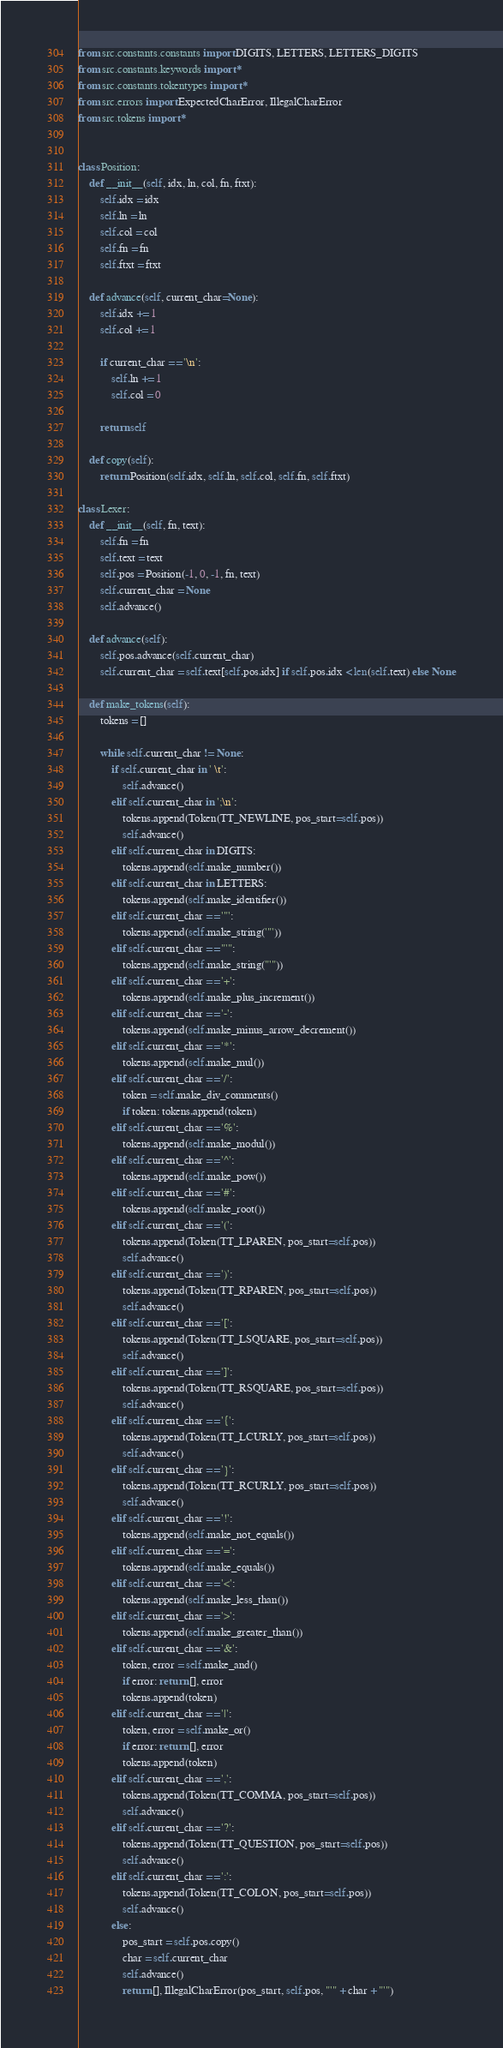Convert code to text. <code><loc_0><loc_0><loc_500><loc_500><_Python_>from src.constants.constants import DIGITS, LETTERS, LETTERS_DIGITS
from src.constants.keywords import *
from src.constants.tokentypes import *
from src.errors import ExpectedCharError, IllegalCharError
from src.tokens import *


class Position:
	def __init__(self, idx, ln, col, fn, ftxt):
		self.idx = idx
		self.ln = ln
		self.col = col
		self.fn = fn
		self.ftxt = ftxt
	
	def advance(self, current_char=None):
		self.idx += 1
		self.col += 1

		if current_char == '\n':
			self.ln += 1
			self.col = 0
		
		return self
	
	def copy(self):
		return Position(self.idx, self.ln, self.col, self.fn, self.ftxt)

class Lexer:
	def __init__(self, fn, text):
		self.fn = fn
		self.text = text
		self.pos = Position(-1, 0, -1, fn, text)
		self.current_char = None
		self.advance()

	def advance(self):
		self.pos.advance(self.current_char)
		self.current_char = self.text[self.pos.idx] if self.pos.idx < len(self.text) else None

	def make_tokens(self):
		tokens = []

		while self.current_char != None:
			if self.current_char in ' \t':
				self.advance()
			elif self.current_char in ';\n':
				tokens.append(Token(TT_NEWLINE, pos_start=self.pos))
				self.advance()
			elif self.current_char in DIGITS:
				tokens.append(self.make_number())
			elif self.current_char in LETTERS:
				tokens.append(self.make_identifier())
			elif self.current_char == '"':
				tokens.append(self.make_string('"'))
			elif self.current_char == "'":
				tokens.append(self.make_string("'"))
			elif self.current_char == '+':
				tokens.append(self.make_plus_increment())
			elif self.current_char == '-':
				tokens.append(self.make_minus_arrow_decrement())
			elif self.current_char == '*':
				tokens.append(self.make_mul())
			elif self.current_char == '/':
				token = self.make_div_comments()
				if token: tokens.append(token)
			elif self.current_char == '%':
				tokens.append(self.make_modul())
			elif self.current_char == '^':
				tokens.append(self.make_pow())
			elif self.current_char == '#':
				tokens.append(self.make_root())
			elif self.current_char == '(':
				tokens.append(Token(TT_LPAREN, pos_start=self.pos))
				self.advance()
			elif self.current_char == ')':
				tokens.append(Token(TT_RPAREN, pos_start=self.pos))
				self.advance()
			elif self.current_char == '[':
				tokens.append(Token(TT_LSQUARE, pos_start=self.pos))
				self.advance()
			elif self.current_char == ']':
				tokens.append(Token(TT_RSQUARE, pos_start=self.pos))
				self.advance()
			elif self.current_char == '{':
				tokens.append(Token(TT_LCURLY, pos_start=self.pos))
				self.advance()
			elif self.current_char == '}':
				tokens.append(Token(TT_RCURLY, pos_start=self.pos))
				self.advance()
			elif self.current_char == '!':
				tokens.append(self.make_not_equals())
			elif self.current_char == '=':
				tokens.append(self.make_equals())
			elif self.current_char == '<':
				tokens.append(self.make_less_than())
			elif self.current_char == '>':
				tokens.append(self.make_greater_than())
			elif self.current_char == '&':
				token, error = self.make_and()
				if error: return [], error
				tokens.append(token)
			elif self.current_char == '|':
				token, error = self.make_or()
				if error: return [], error
				tokens.append(token)
			elif self.current_char == ',':
				tokens.append(Token(TT_COMMA, pos_start=self.pos))
				self.advance()
			elif self.current_char == '?':
				tokens.append(Token(TT_QUESTION, pos_start=self.pos))
				self.advance()
			elif self.current_char == ':':
				tokens.append(Token(TT_COLON, pos_start=self.pos))
				self.advance()
			else:
				pos_start = self.pos.copy()
				char = self.current_char
				self.advance()
				return [], IllegalCharError(pos_start, self.pos, "'" + char + "'")
</code> 